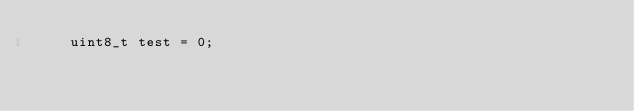Convert code to text. <code><loc_0><loc_0><loc_500><loc_500><_C++_>	uint8_t test = 0;</code> 